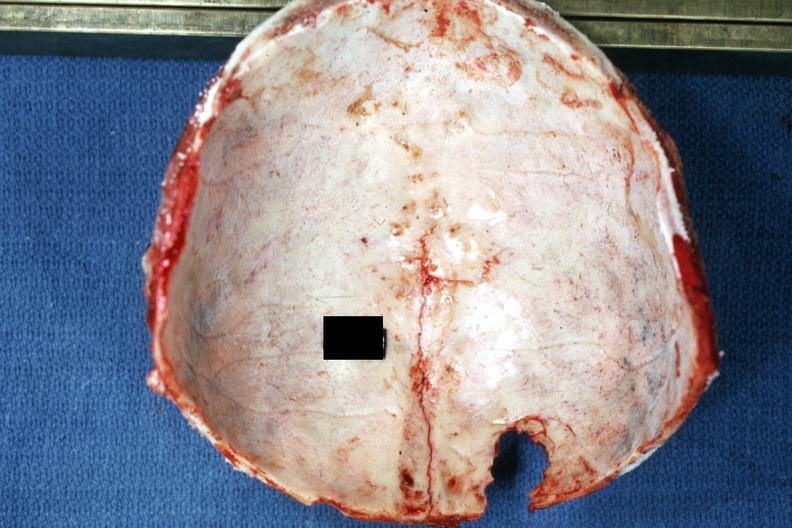what is present?
Answer the question using a single word or phrase. Bone, calvarium 